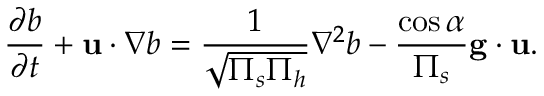<formula> <loc_0><loc_0><loc_500><loc_500>\frac { \partial b } { \partial t } + u \cdot \nabla b = \frac { 1 } { \sqrt { \Pi _ { s } \Pi _ { h } } } \nabla ^ { 2 } b - \frac { \cos \alpha } { \Pi _ { s } } g \cdot u .</formula> 